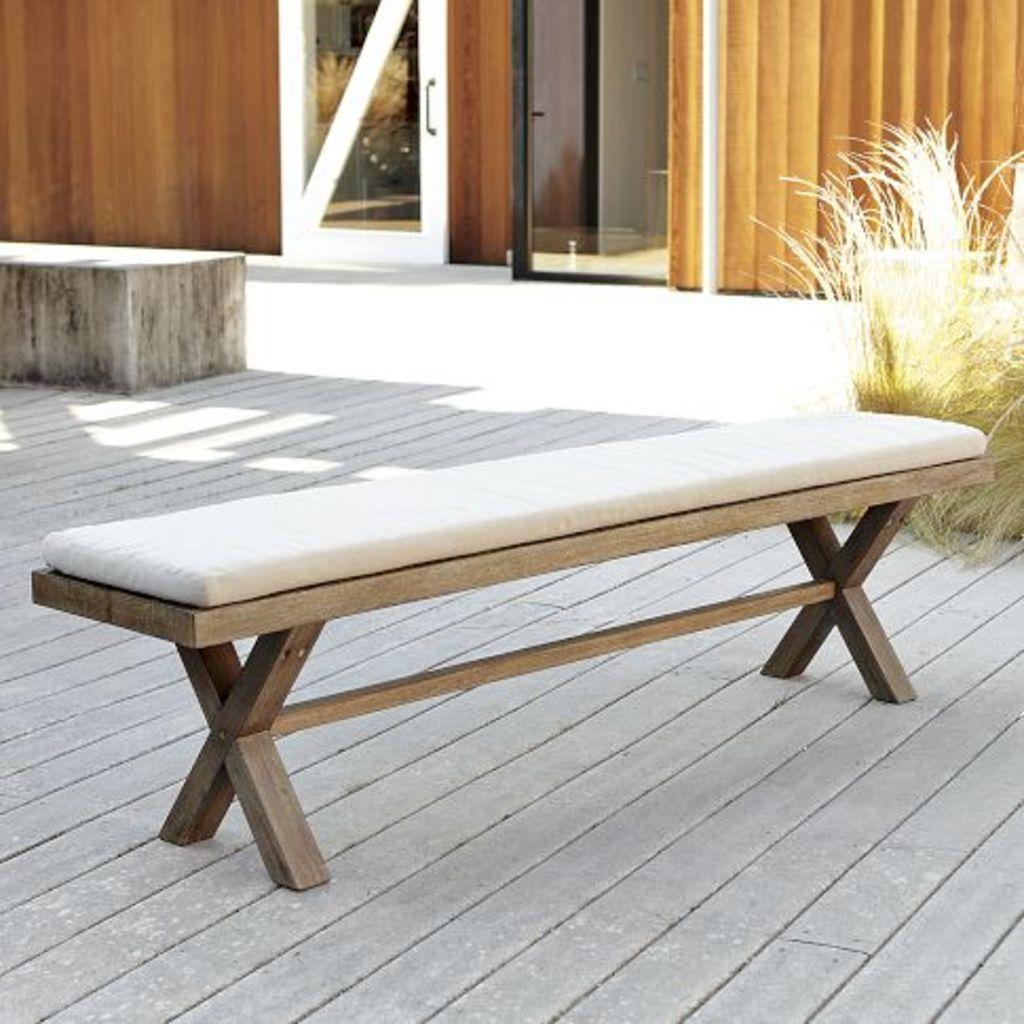Please provide a concise description of this image. In this image I can see a bench which is brown in color and on it I can see a white colored object. I can see some grass, the wooden wall and a white colored door and I can see the ash colored floor. 